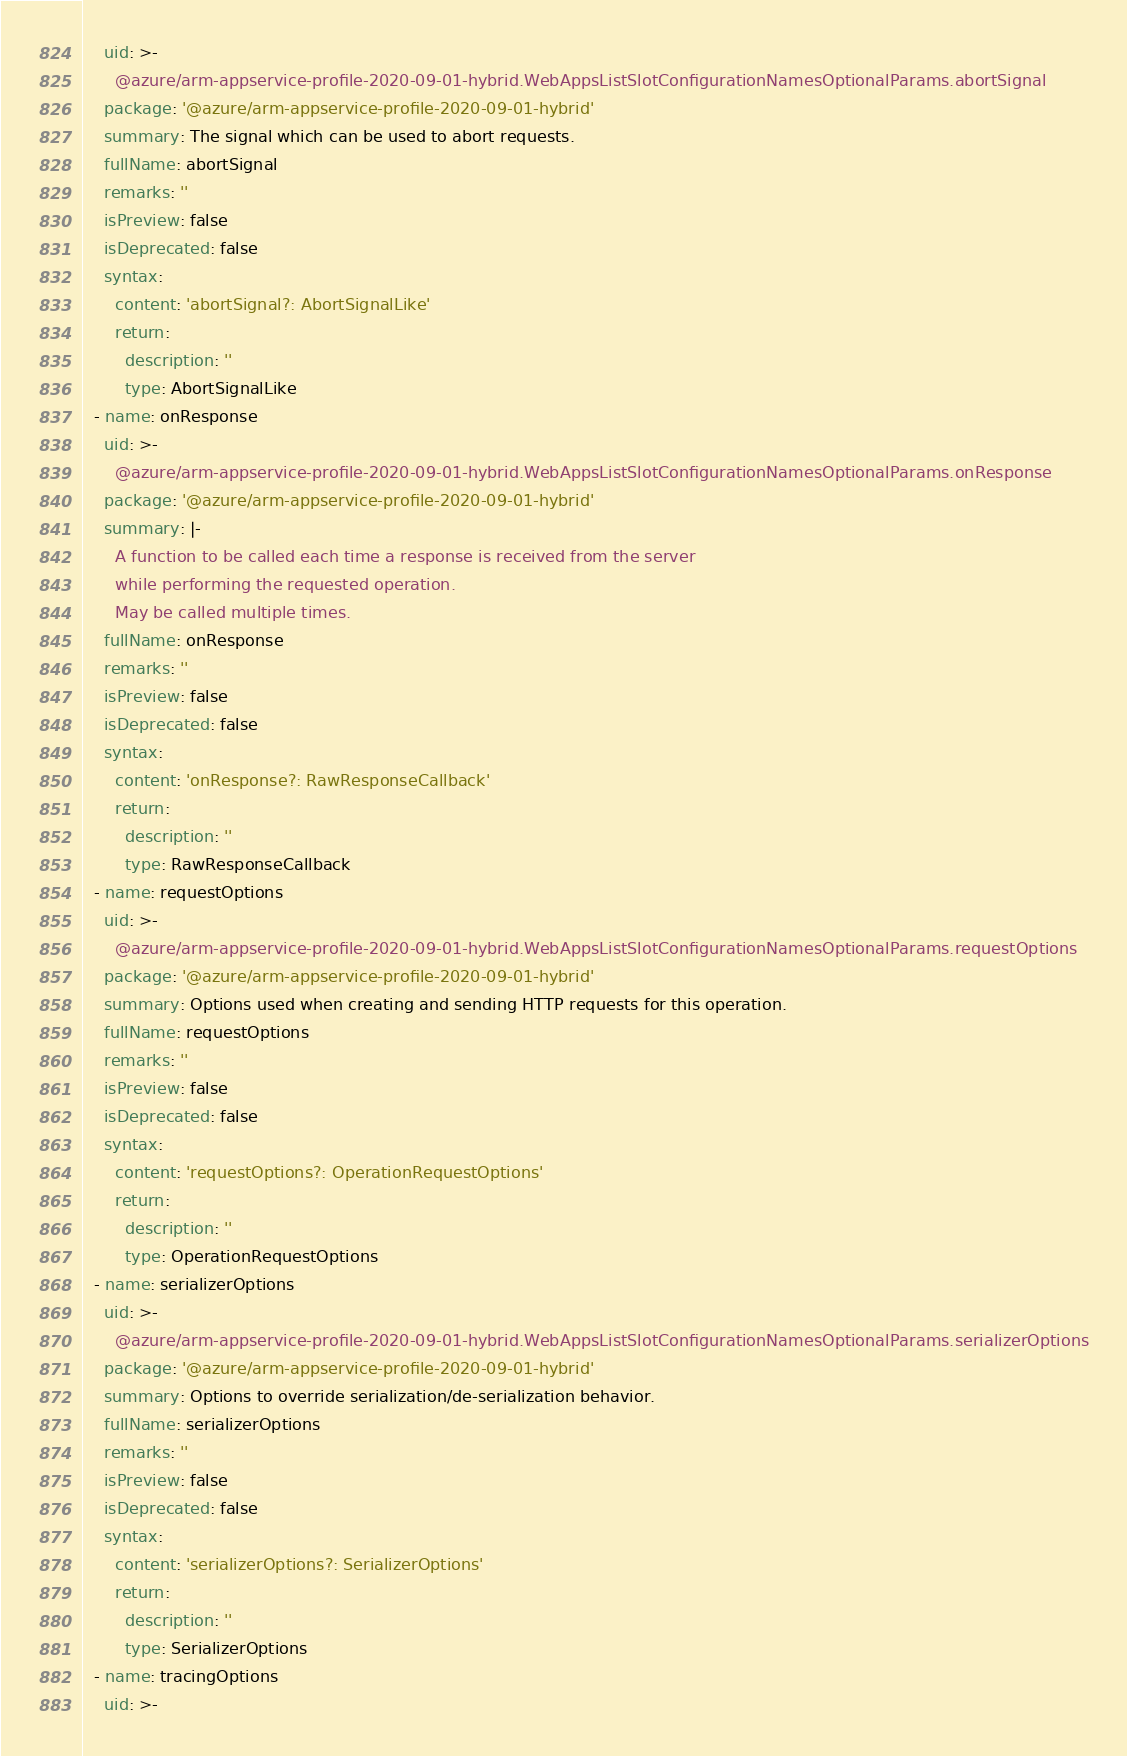<code> <loc_0><loc_0><loc_500><loc_500><_YAML_>    uid: >-
      @azure/arm-appservice-profile-2020-09-01-hybrid.WebAppsListSlotConfigurationNamesOptionalParams.abortSignal
    package: '@azure/arm-appservice-profile-2020-09-01-hybrid'
    summary: The signal which can be used to abort requests.
    fullName: abortSignal
    remarks: ''
    isPreview: false
    isDeprecated: false
    syntax:
      content: 'abortSignal?: AbortSignalLike'
      return:
        description: ''
        type: AbortSignalLike
  - name: onResponse
    uid: >-
      @azure/arm-appservice-profile-2020-09-01-hybrid.WebAppsListSlotConfigurationNamesOptionalParams.onResponse
    package: '@azure/arm-appservice-profile-2020-09-01-hybrid'
    summary: |-
      A function to be called each time a response is received from the server
      while performing the requested operation.
      May be called multiple times.
    fullName: onResponse
    remarks: ''
    isPreview: false
    isDeprecated: false
    syntax:
      content: 'onResponse?: RawResponseCallback'
      return:
        description: ''
        type: RawResponseCallback
  - name: requestOptions
    uid: >-
      @azure/arm-appservice-profile-2020-09-01-hybrid.WebAppsListSlotConfigurationNamesOptionalParams.requestOptions
    package: '@azure/arm-appservice-profile-2020-09-01-hybrid'
    summary: Options used when creating and sending HTTP requests for this operation.
    fullName: requestOptions
    remarks: ''
    isPreview: false
    isDeprecated: false
    syntax:
      content: 'requestOptions?: OperationRequestOptions'
      return:
        description: ''
        type: OperationRequestOptions
  - name: serializerOptions
    uid: >-
      @azure/arm-appservice-profile-2020-09-01-hybrid.WebAppsListSlotConfigurationNamesOptionalParams.serializerOptions
    package: '@azure/arm-appservice-profile-2020-09-01-hybrid'
    summary: Options to override serialization/de-serialization behavior.
    fullName: serializerOptions
    remarks: ''
    isPreview: false
    isDeprecated: false
    syntax:
      content: 'serializerOptions?: SerializerOptions'
      return:
        description: ''
        type: SerializerOptions
  - name: tracingOptions
    uid: >-</code> 